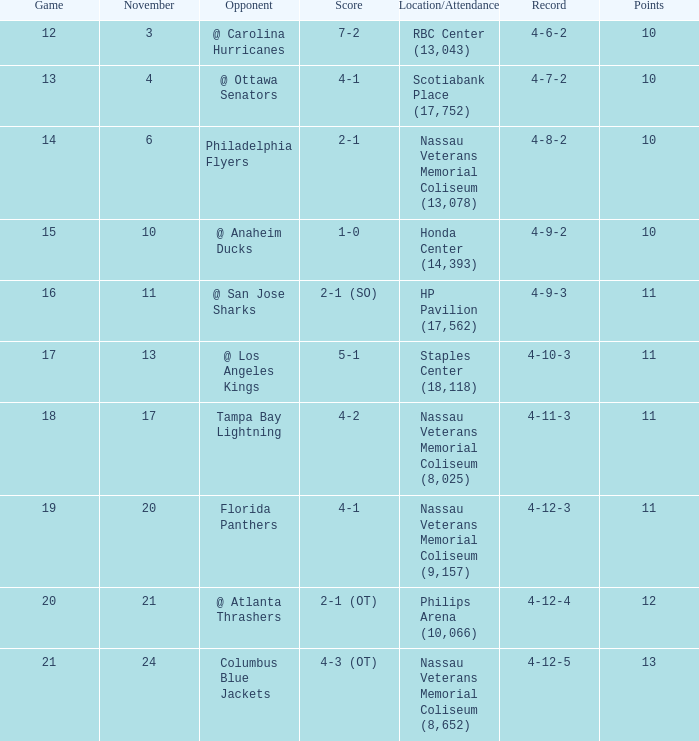What is each record for game 13? 4-7-2. 